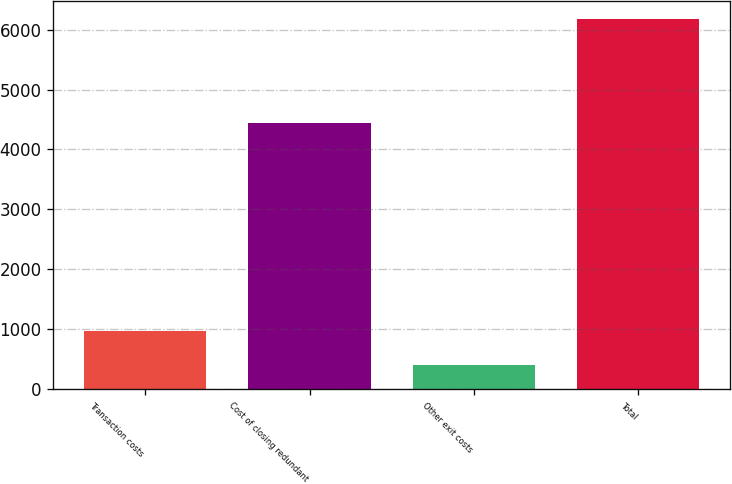<chart> <loc_0><loc_0><loc_500><loc_500><bar_chart><fcel>Transaction costs<fcel>Cost of closing redundant<fcel>Other exit costs<fcel>Total<nl><fcel>973.3<fcel>4442<fcel>395<fcel>6178<nl></chart> 